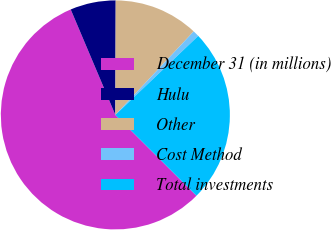Convert chart to OTSL. <chart><loc_0><loc_0><loc_500><loc_500><pie_chart><fcel>December 31 (in millions)<fcel>Hulu<fcel>Other<fcel>Cost Method<fcel>Total investments<nl><fcel>56.15%<fcel>6.42%<fcel>11.94%<fcel>0.89%<fcel>24.59%<nl></chart> 